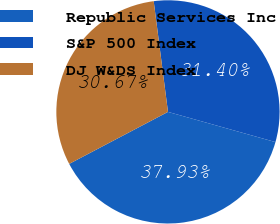Convert chart. <chart><loc_0><loc_0><loc_500><loc_500><pie_chart><fcel>Republic Services Inc<fcel>S&P 500 Index<fcel>DJ W&DS Index<nl><fcel>37.93%<fcel>31.4%<fcel>30.67%<nl></chart> 